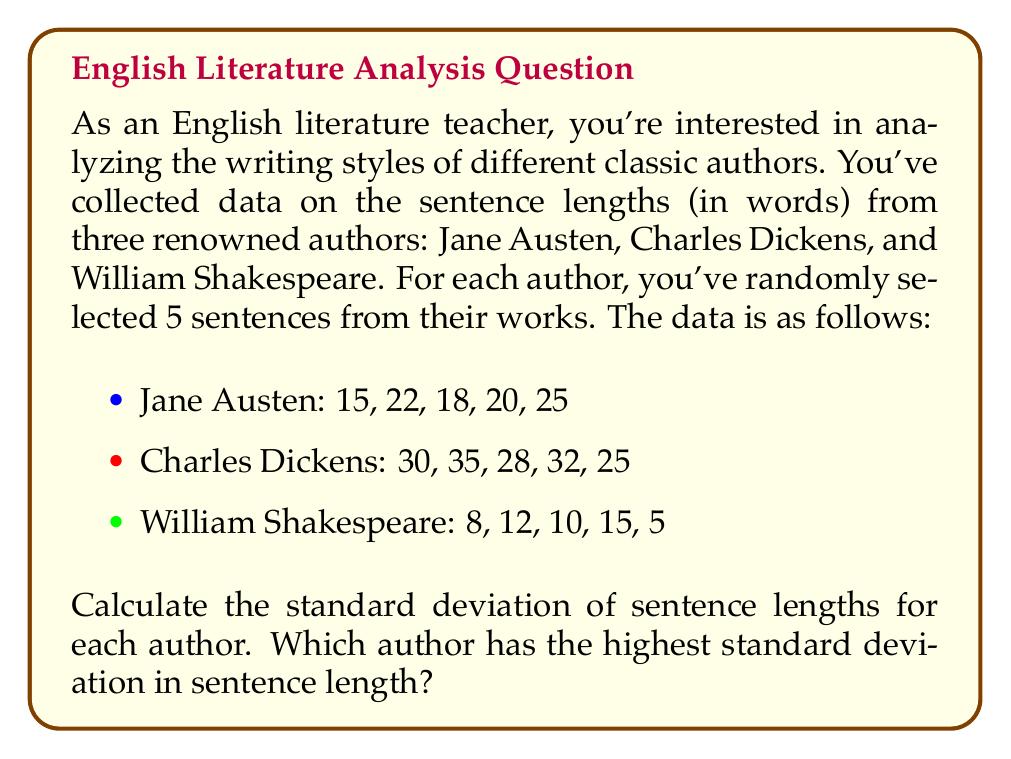Can you solve this math problem? To solve this problem, we'll calculate the standard deviation for each author's sentence lengths using the following steps:

1. Calculate the mean (average) sentence length for each author.
2. Calculate the squared differences from the mean for each sentence.
3. Calculate the variance by finding the average of the squared differences.
4. Take the square root of the variance to get the standard deviation.

Let's go through this process for each author:

1. Jane Austen:

Mean: $\bar{x} = \frac{15 + 22 + 18 + 20 + 25}{5} = 20$

Squared differences: $(15-20)^2 = 25$, $(22-20)^2 = 4$, $(18-20)^2 = 4$, $(20-20)^2 = 0$, $(25-20)^2 = 25$

Variance: $\sigma^2 = \frac{25 + 4 + 4 + 0 + 25}{5} = \frac{58}{5} = 11.6$

Standard deviation: $\sigma = \sqrt{11.6} \approx 3.41$

2. Charles Dickens:

Mean: $\bar{x} = \frac{30 + 35 + 28 + 32 + 25}{5} = 30$

Squared differences: $(30-30)^2 = 0$, $(35-30)^2 = 25$, $(28-30)^2 = 4$, $(32-30)^2 = 4$, $(25-30)^2 = 25$

Variance: $\sigma^2 = \frac{0 + 25 + 4 + 4 + 25}{5} = \frac{58}{5} = 11.6$

Standard deviation: $\sigma = \sqrt{11.6} \approx 3.41$

3. William Shakespeare:

Mean: $\bar{x} = \frac{8 + 12 + 10 + 15 + 5}{5} = 10$

Squared differences: $(8-10)^2 = 4$, $(12-10)^2 = 4$, $(10-10)^2 = 0$, $(15-10)^2 = 25$, $(5-10)^2 = 25$

Variance: $\sigma^2 = \frac{4 + 4 + 0 + 25 + 25}{5} = \frac{58}{5} = 11.6$

Standard deviation: $\sigma = \sqrt{11.6} \approx 3.41$
Answer: The standard deviations for each author are:

Jane Austen: $\sigma \approx 3.41$
Charles Dickens: $\sigma \approx 3.41$
William Shakespeare: $\sigma \approx 3.41$

Surprisingly, all three authors have the same standard deviation in this sample. Therefore, there is no single author with the highest standard deviation; they are all equal. 